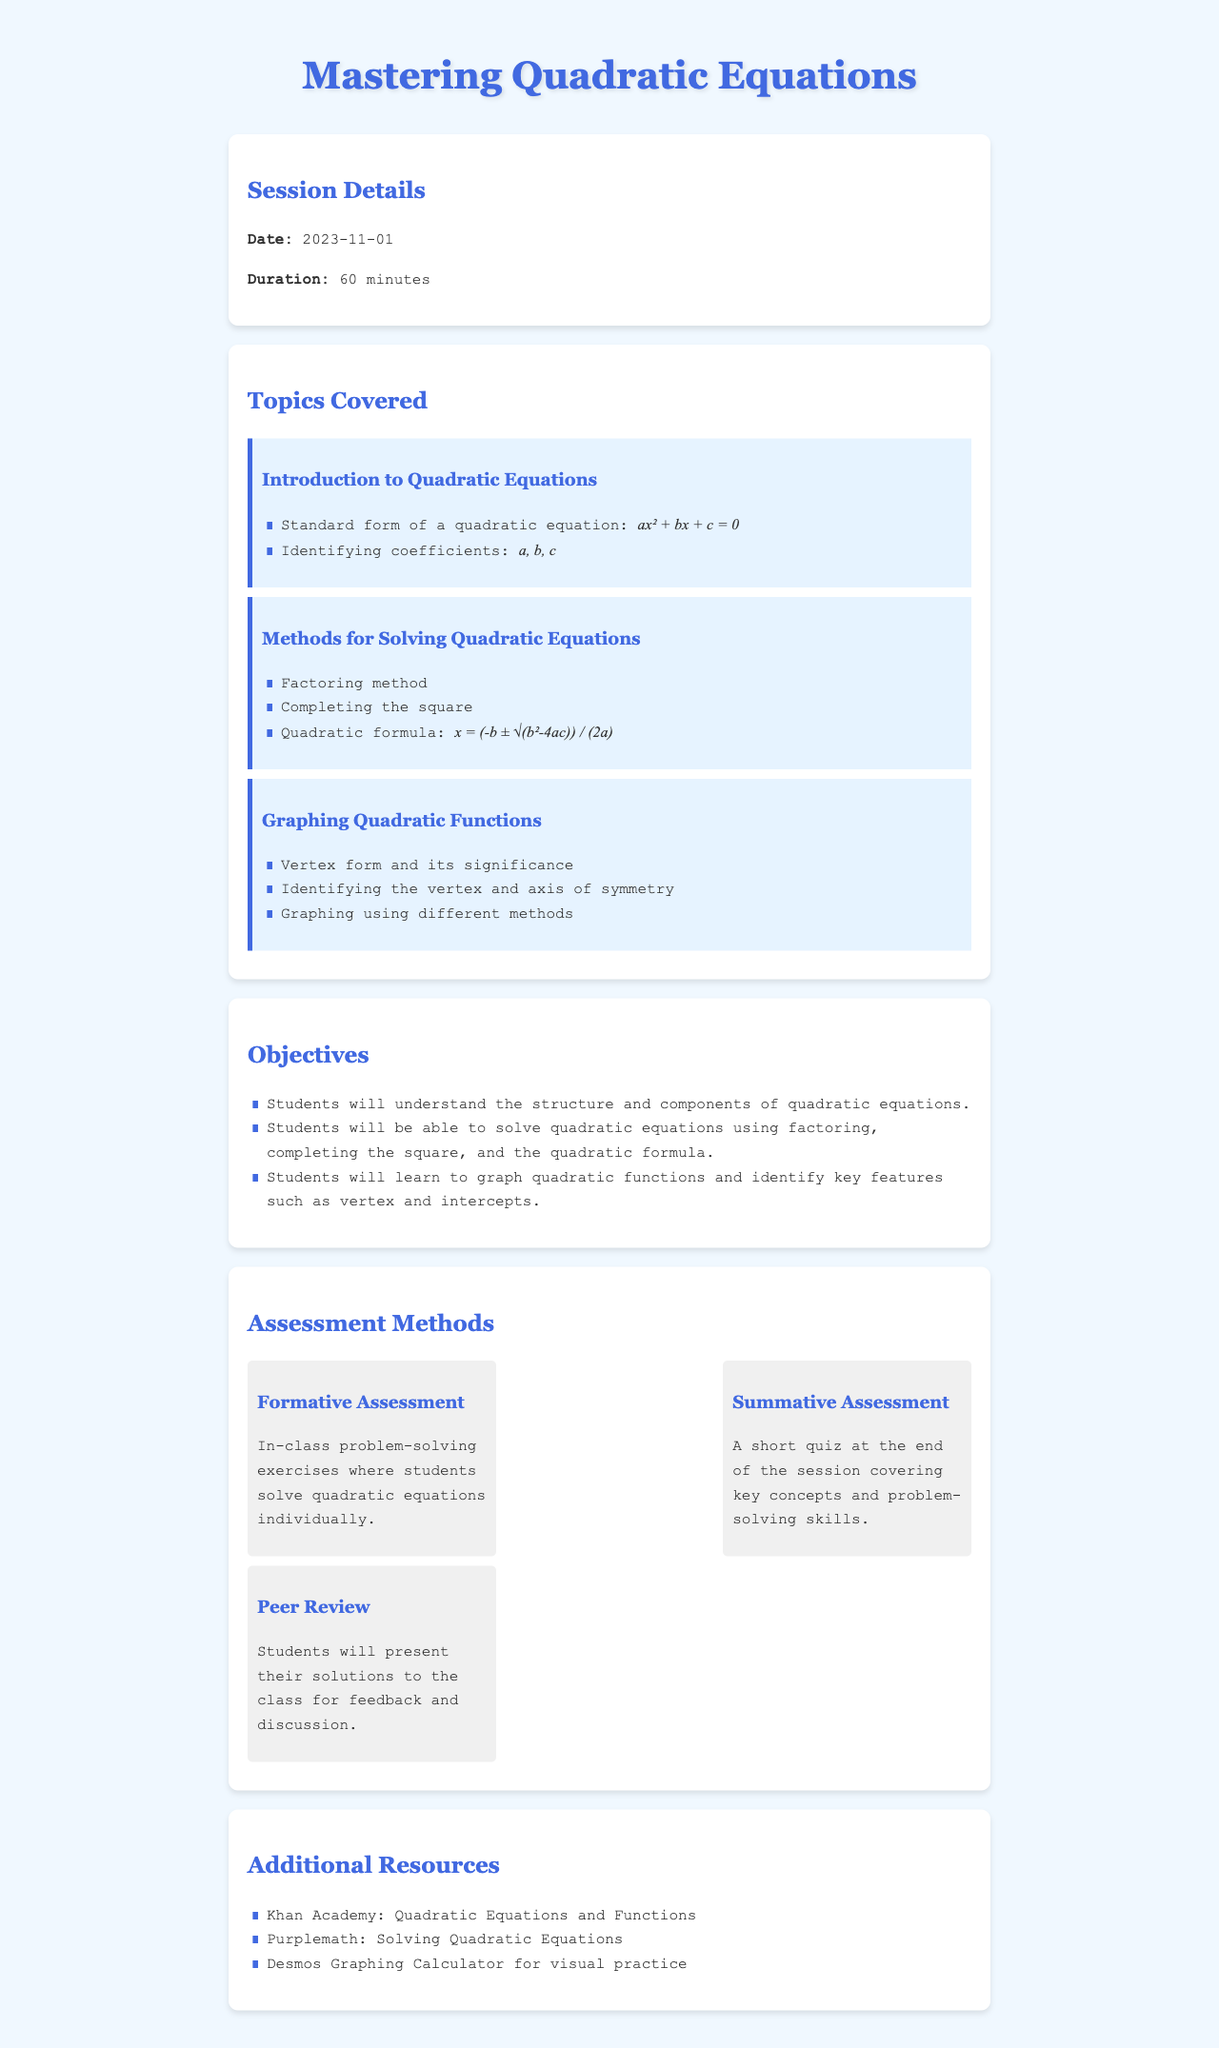What is the title of the lesson plan? The title is prominently displayed at the top of the document and specifies the main topic of the session.
Answer: Mastering Quadratic Equations What is the date of the session? The date is stated in the Session Details section of the document.
Answer: 2023-11-01 How long is the duration of the tutoring session? The duration is provided in the Session Details section of the document.
Answer: 60 minutes What are the three methods for solving quadratic equations mentioned? The methods listed in the document are important for achieving the lesson objectives.
Answer: Factoring method, Completing the square, Quadratic formula What is one objective for the students in this session? The objectives outline what students should learn, and one of them indicates the understanding of equations.
Answer: Students will understand the structure and components of quadratic equations What type of assessment is conducted at the end of the session? This assessment is specified in the Assessment Methods section and focuses on evaluating students' understanding.
Answer: Short quiz What resource is suggested for visual practice? The Additional Resources section provides options for students to further their learning.
Answer: Desmos Graphing Calculator What is the significance of the vertex form mentioned in the document? This concept is introduced in the Graphing Quadratic Functions topic and serves a key role in understanding the graph.
Answer: It's significant for identifying the vertex and axis of symmetry What is a key feature students will learn to identify when graphing quadratic functions? This details one of the specific skills to be developed in the session and indicates a fundamental aspect of graphing.
Answer: Vertex and intercepts 